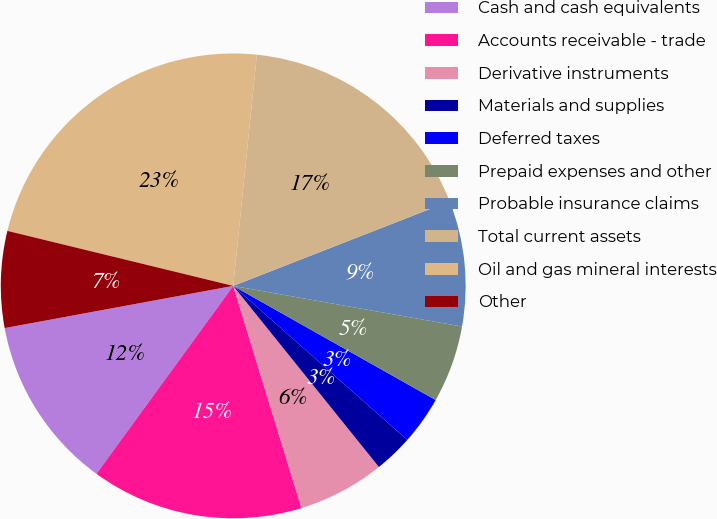Convert chart to OTSL. <chart><loc_0><loc_0><loc_500><loc_500><pie_chart><fcel>Cash and cash equivalents<fcel>Accounts receivable - trade<fcel>Derivative instruments<fcel>Materials and supplies<fcel>Deferred taxes<fcel>Prepaid expenses and other<fcel>Probable insurance claims<fcel>Total current assets<fcel>Oil and gas mineral interests<fcel>Other<nl><fcel>12.08%<fcel>14.76%<fcel>6.04%<fcel>2.69%<fcel>3.36%<fcel>5.37%<fcel>8.73%<fcel>17.45%<fcel>22.82%<fcel>6.71%<nl></chart> 